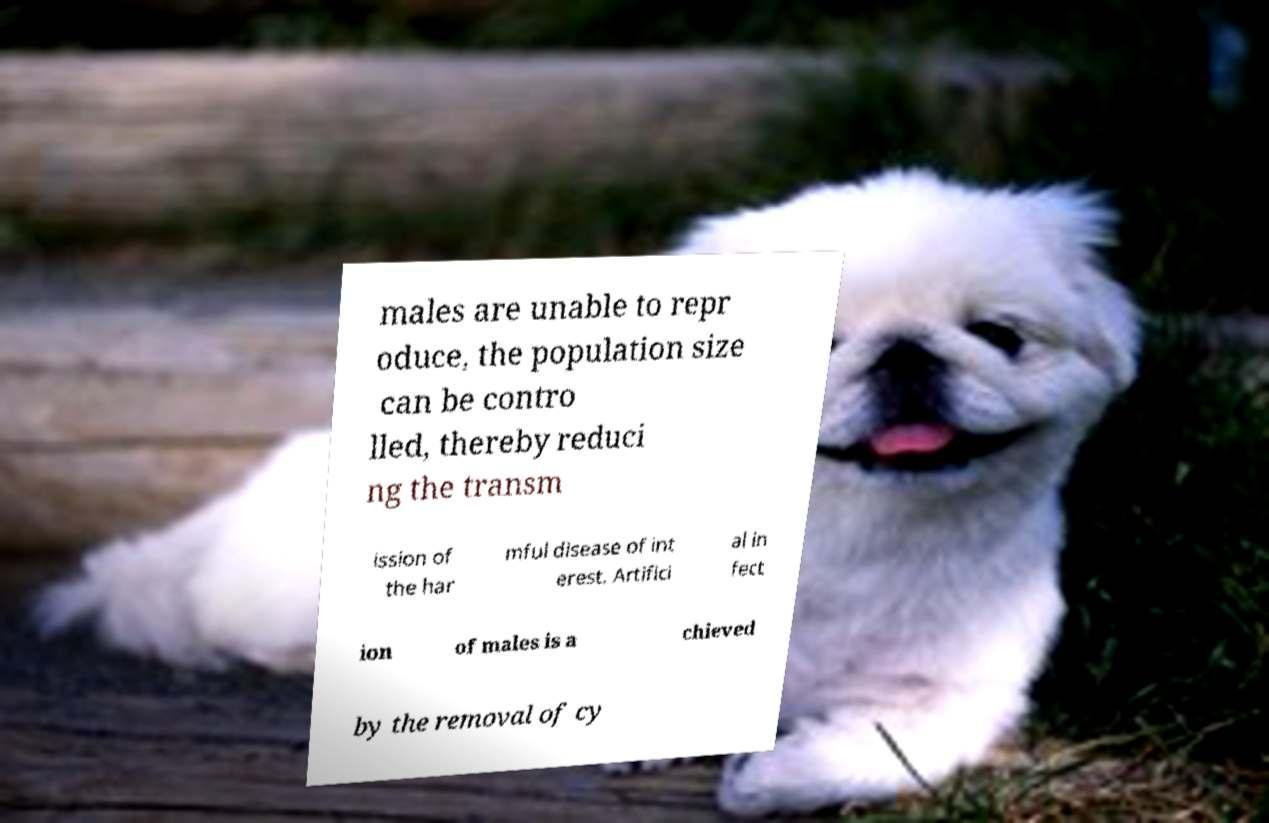Can you accurately transcribe the text from the provided image for me? males are unable to repr oduce, the population size can be contro lled, thereby reduci ng the transm ission of the har mful disease of int erest. Artifici al in fect ion of males is a chieved by the removal of cy 